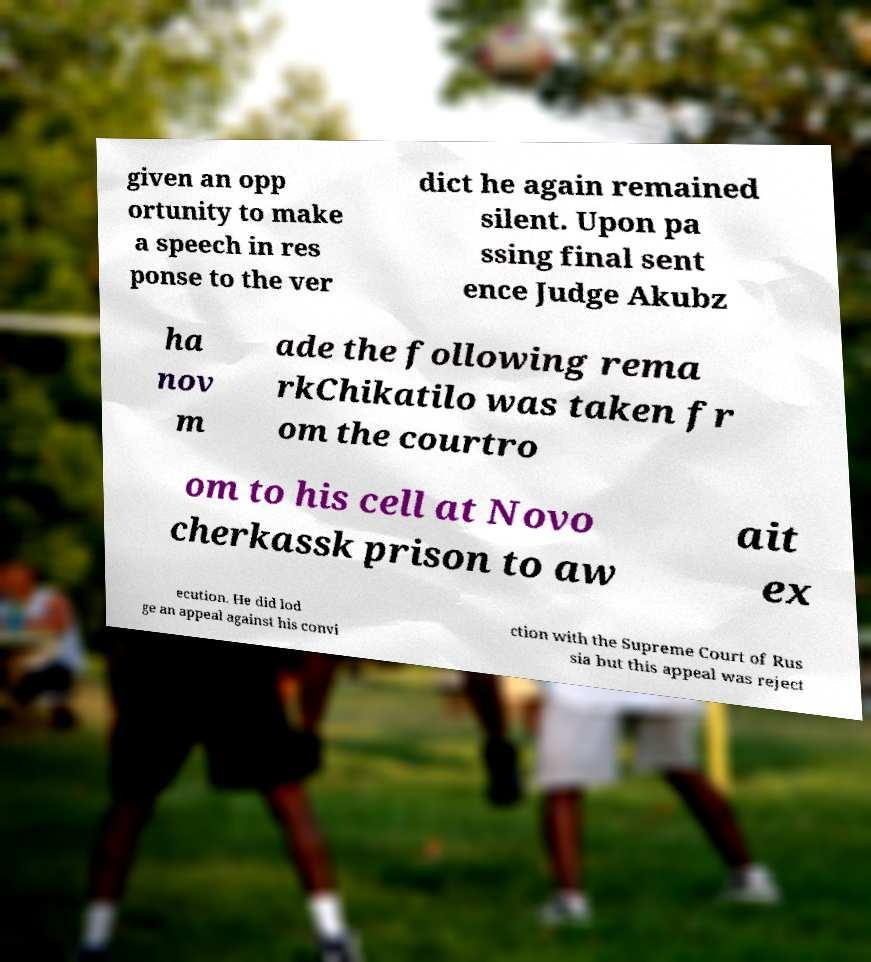There's text embedded in this image that I need extracted. Can you transcribe it verbatim? given an opp ortunity to make a speech in res ponse to the ver dict he again remained silent. Upon pa ssing final sent ence Judge Akubz ha nov m ade the following rema rkChikatilo was taken fr om the courtro om to his cell at Novo cherkassk prison to aw ait ex ecution. He did lod ge an appeal against his convi ction with the Supreme Court of Rus sia but this appeal was reject 